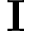<formula> <loc_0><loc_0><loc_500><loc_500>I</formula> 